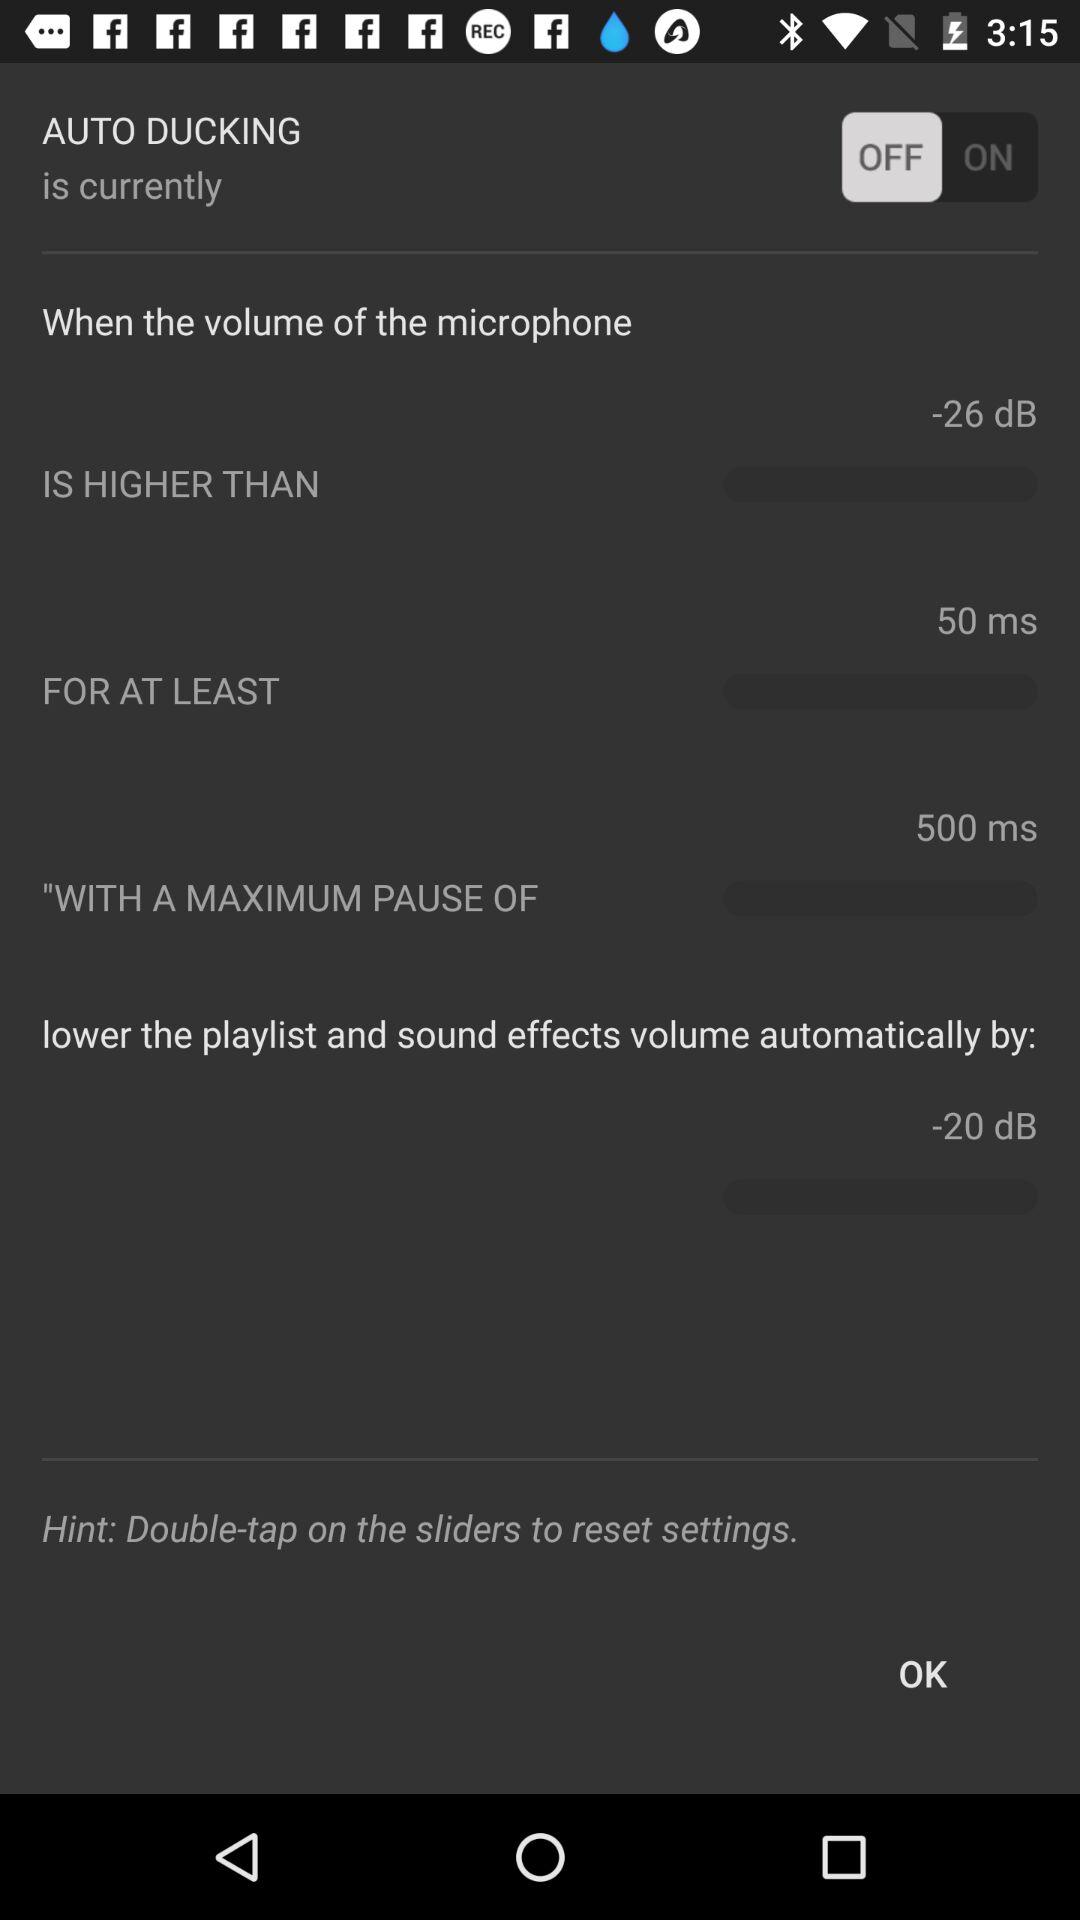What is the maximum pause time? The maximum pause time is 500 ms. 